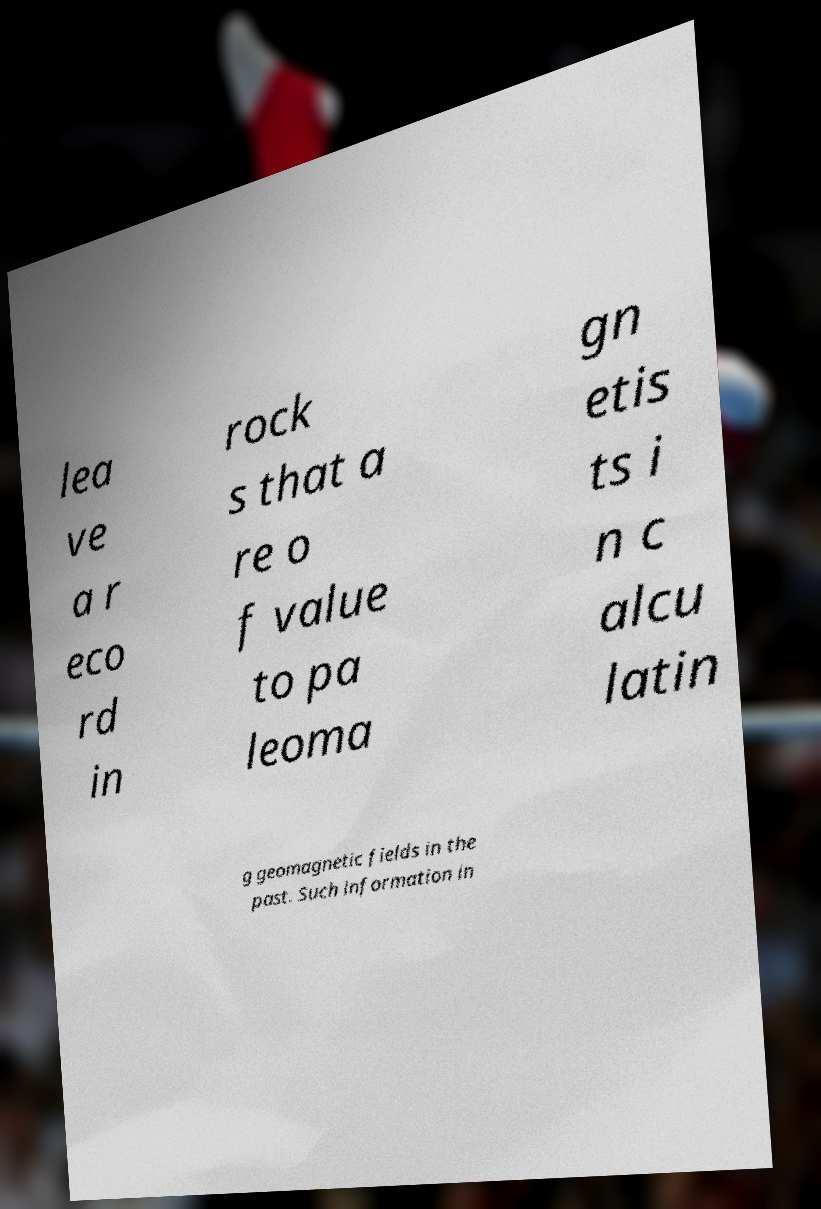Please read and relay the text visible in this image. What does it say? lea ve a r eco rd in rock s that a re o f value to pa leoma gn etis ts i n c alcu latin g geomagnetic fields in the past. Such information in 